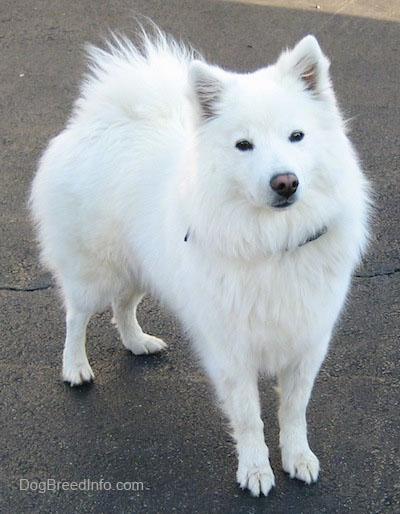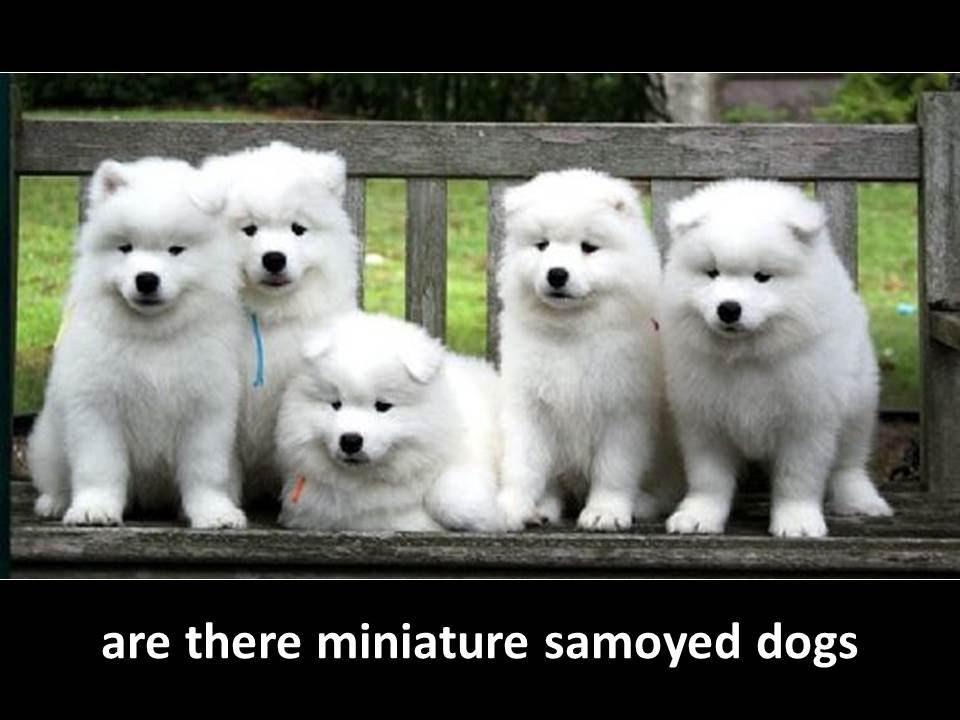The first image is the image on the left, the second image is the image on the right. Examine the images to the left and right. Is the description "There is a white dog facing the right with trees in the background." accurate? Answer yes or no. No. The first image is the image on the left, the second image is the image on the right. For the images shown, is this caption "There are two samoyed dogs outside in the center of the images." true? Answer yes or no. No. 